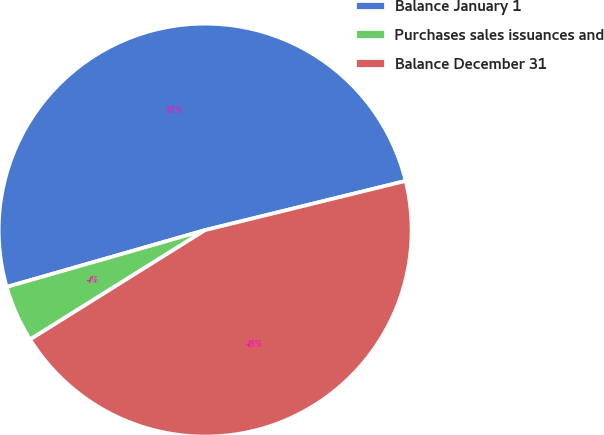Convert chart. <chart><loc_0><loc_0><loc_500><loc_500><pie_chart><fcel>Balance January 1<fcel>Purchases sales issuances and<fcel>Balance December 31<nl><fcel>50.61%<fcel>4.45%<fcel>44.94%<nl></chart> 